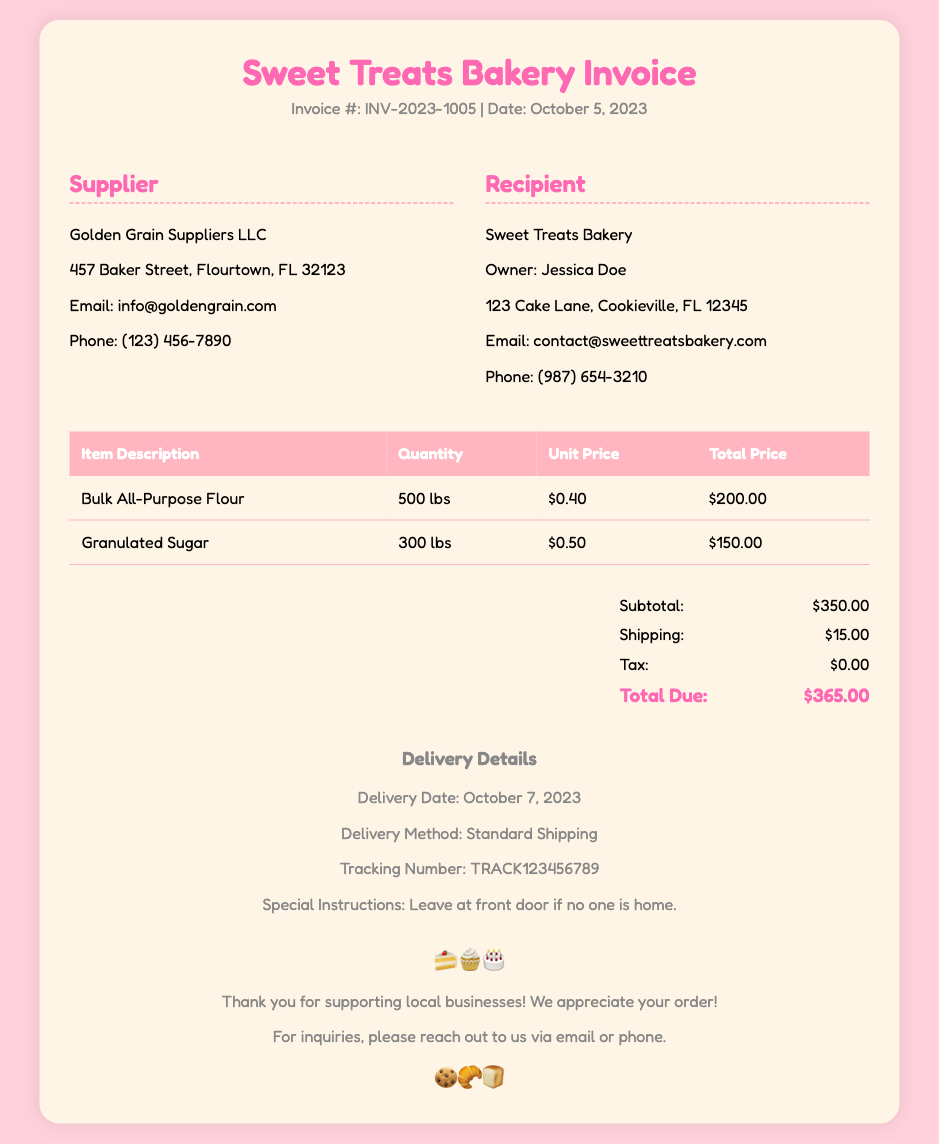What is the invoice number? The invoice number is listed in the header of the document.
Answer: INV-2023-1005 What date was the invoice issued? The date of the invoice is mentioned right next to the invoice number.
Answer: October 5, 2023 Who is the supplier? The supplier's information is found in the supplier section of the document.
Answer: Golden Grain Suppliers LLC What is the total cost for the bulk flour? The total cost for the bulk flour is provided in the itemized table.
Answer: $200.00 What is the quantity of granulated sugar ordered? The quantity is specified in the itemized list under the granulated sugar description.
Answer: 300 lbs What is the delivery date? The delivery date is stated in the delivery details section.
Answer: October 7, 2023 What is the subtotal before shipping and tax? The subtotal is calculated as part of the summary details provided in the document.
Answer: $350.00 What is the total due amount? The total due amount summarizes the total costs in the document's summary section.
Answer: $365.00 What method will be used for delivery? The delivery method is specified in the delivery details section.
Answer: Standard Shipping 